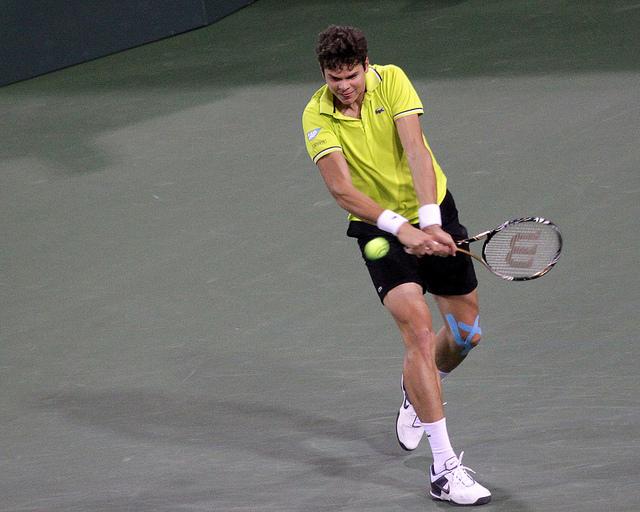Is there a blue tape on his knee?
Give a very brief answer. Yes. Are both feet in contact with the ground?
Keep it brief. No. How many shadows are present?
Answer briefly. 2. Why is there blue tape on his knee?
Quick response, please. Injury. 